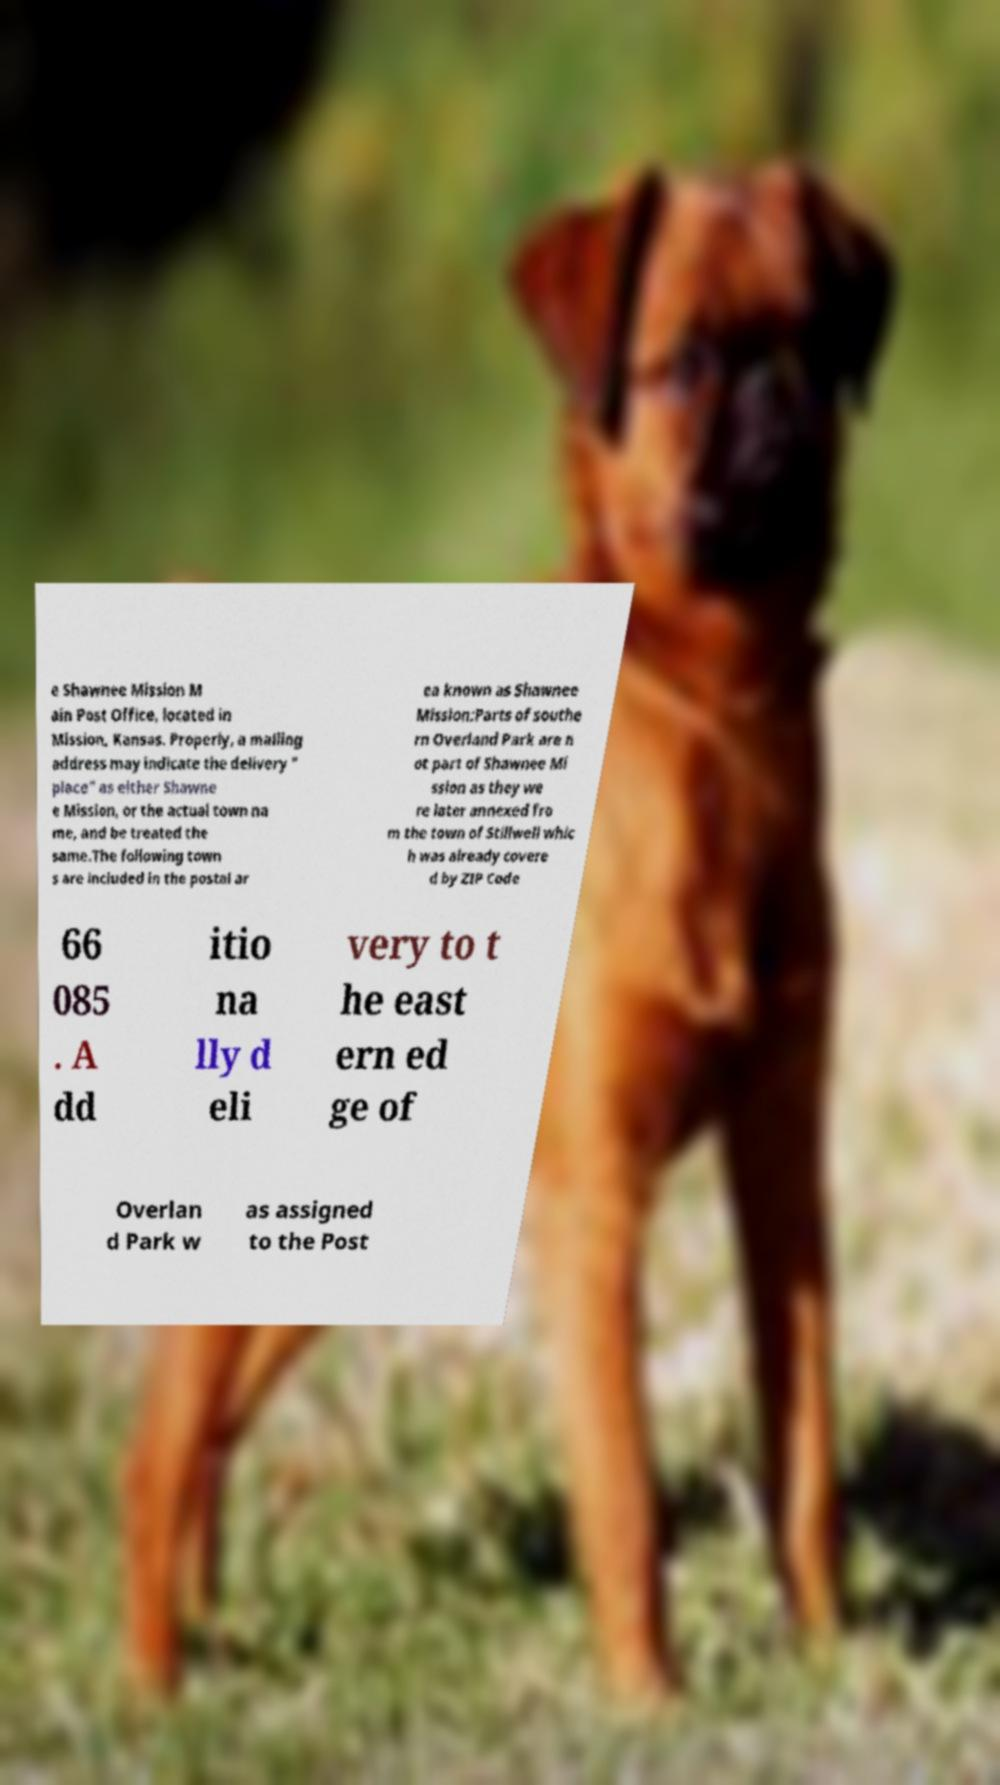Could you assist in decoding the text presented in this image and type it out clearly? e Shawnee Mission M ain Post Office, located in Mission, Kansas. Properly, a mailing address may indicate the delivery " place" as either Shawne e Mission, or the actual town na me, and be treated the same.The following town s are included in the postal ar ea known as Shawnee Mission:Parts of southe rn Overland Park are n ot part of Shawnee Mi ssion as they we re later annexed fro m the town of Stillwell whic h was already covere d by ZIP Code 66 085 . A dd itio na lly d eli very to t he east ern ed ge of Overlan d Park w as assigned to the Post 